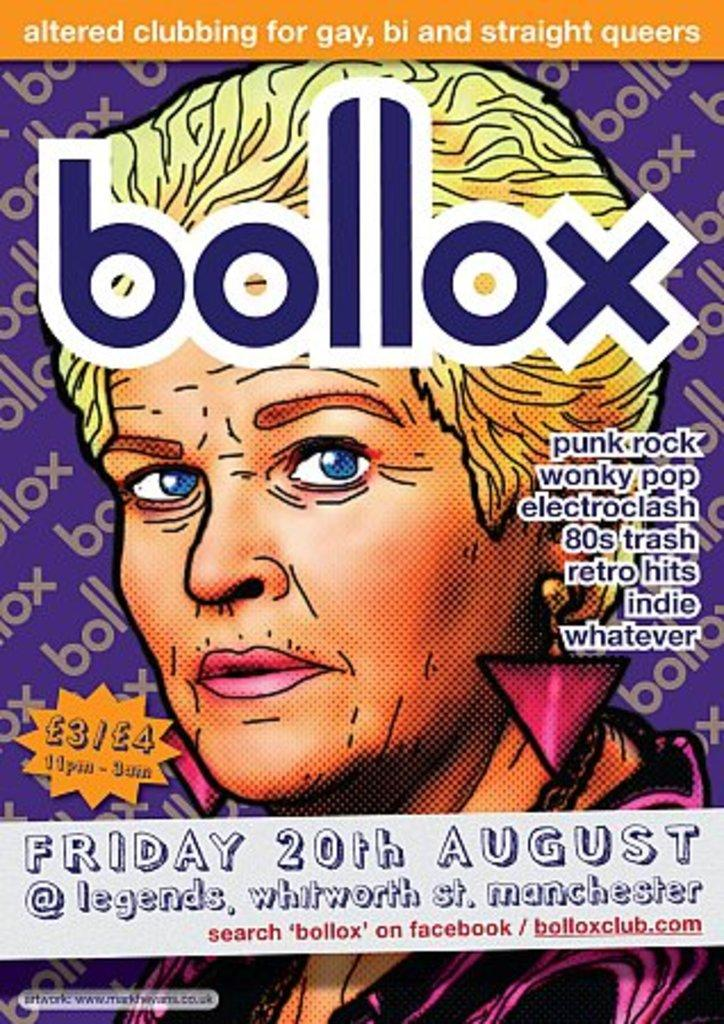What is present in the image that features text? There is a poster in the image that features text. What else can be seen on the poster besides text? There is a picture of a person on the poster. What type of punishment is depicted in the image? There is no punishment depicted in the image; it features a poster with text and a picture of a person. 